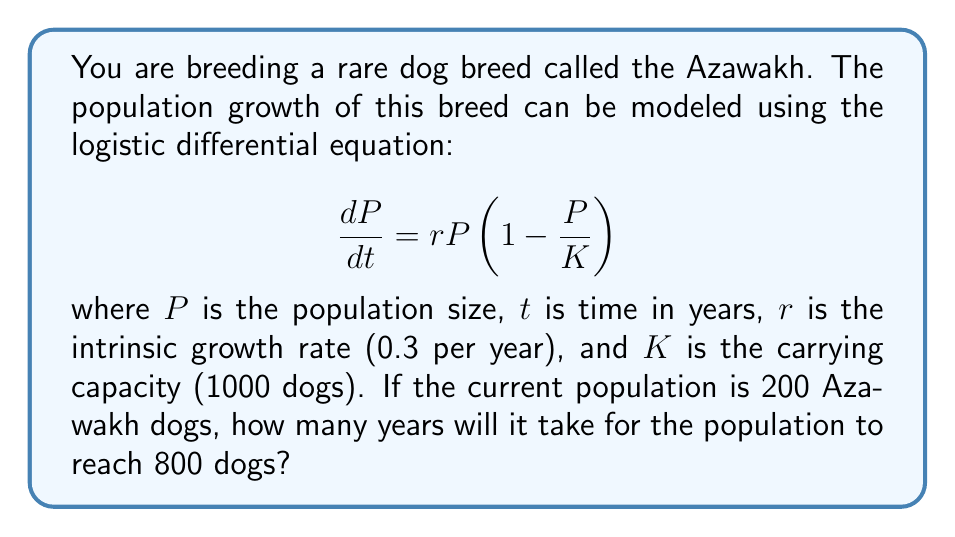Can you answer this question? To solve this problem, we need to use the solution to the logistic differential equation:

$$P(t) = \frac{K}{1 + \left(\frac{K}{P_0} - 1\right)e^{-rt}}$$

where $P_0$ is the initial population.

Given:
$K = 1000$ (carrying capacity)
$r = 0.3$ (intrinsic growth rate)
$P_0 = 200$ (initial population)
$P(t) = 800$ (target population)

Let's substitute these values into the equation:

$$800 = \frac{1000}{1 + \left(\frac{1000}{200} - 1\right)e^{-0.3t}}$$

Now, we need to solve this equation for $t$:

1) Simplify the right side:
   $$800 = \frac{1000}{1 + 4e^{-0.3t}}$$

2) Multiply both sides by $(1 + 4e^{-0.3t})$:
   $$800(1 + 4e^{-0.3t}) = 1000$$

3) Distribute on the left side:
   $$800 + 3200e^{-0.3t} = 1000$$

4) Subtract 800 from both sides:
   $$3200e^{-0.3t} = 200$$

5) Divide both sides by 3200:
   $$e^{-0.3t} = \frac{1}{16}$$

6) Take the natural log of both sides:
   $$-0.3t = \ln\left(\frac{1}{16}\right) = -\ln(16)$$

7) Divide both sides by -0.3:
   $$t = \frac{\ln(16)}{0.3}$$

8) Calculate the final result:
   $$t \approx 9.27$$

Therefore, it will take approximately 9.27 years for the Azawakh population to grow from 200 to 800 dogs.
Answer: 9.27 years 